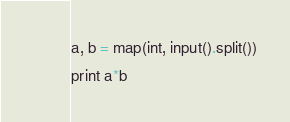<code> <loc_0><loc_0><loc_500><loc_500><_Python_>a, b = map(int, input().split())
print a*b</code> 